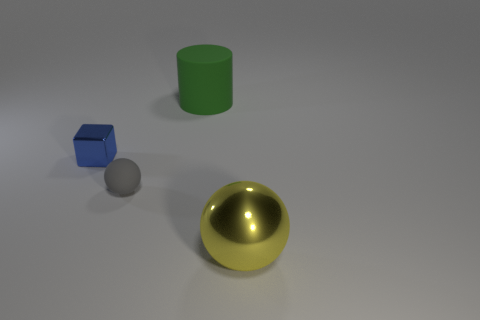Add 2 tiny cyan metallic blocks. How many objects exist? 6 Subtract all big gray metal cylinders. Subtract all small gray matte spheres. How many objects are left? 3 Add 2 small rubber things. How many small rubber things are left? 3 Add 2 large red matte blocks. How many large red matte blocks exist? 2 Subtract 0 purple blocks. How many objects are left? 4 